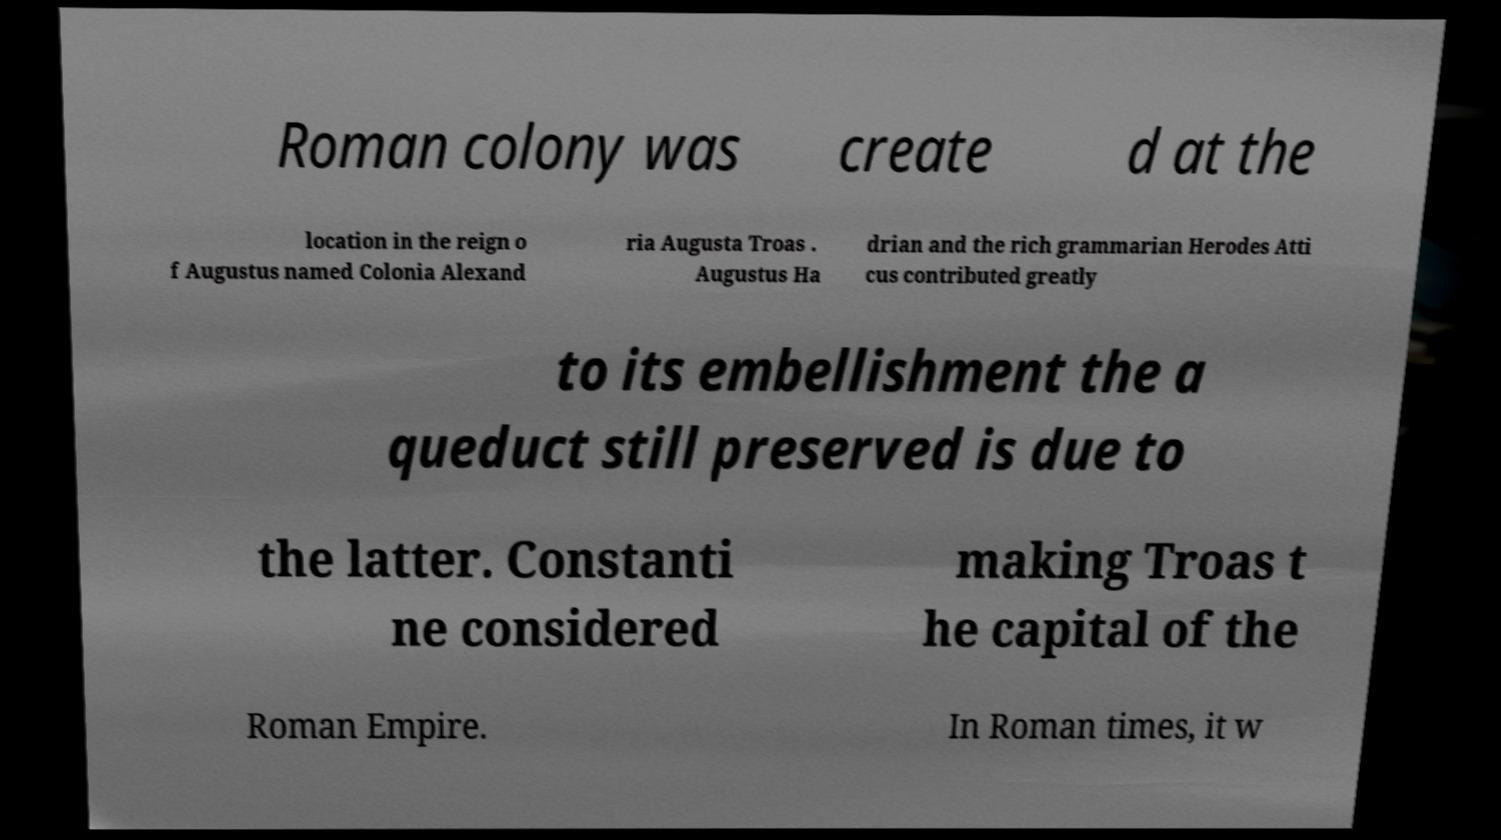Please identify and transcribe the text found in this image. Roman colony was create d at the location in the reign o f Augustus named Colonia Alexand ria Augusta Troas . Augustus Ha drian and the rich grammarian Herodes Atti cus contributed greatly to its embellishment the a queduct still preserved is due to the latter. Constanti ne considered making Troas t he capital of the Roman Empire. In Roman times, it w 